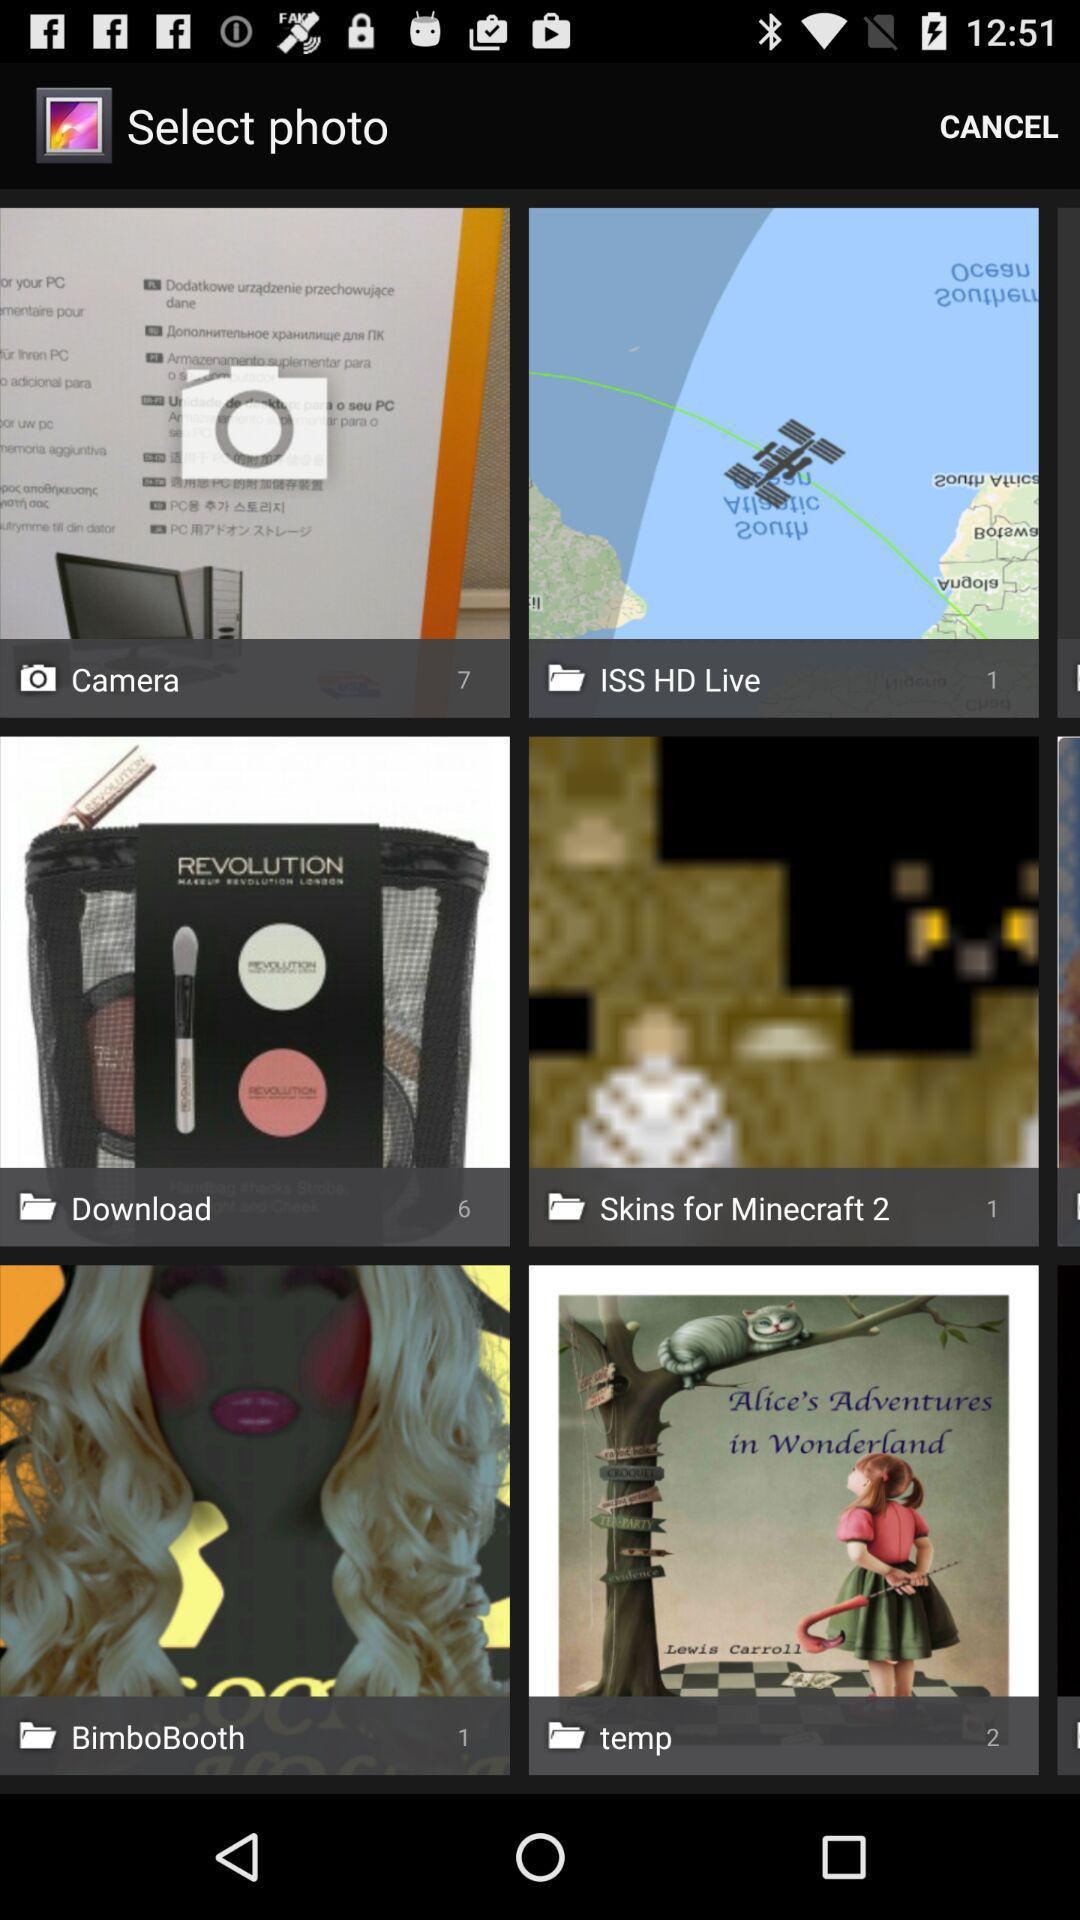What is the number of images in "Camera" album? The number of images is 7. 